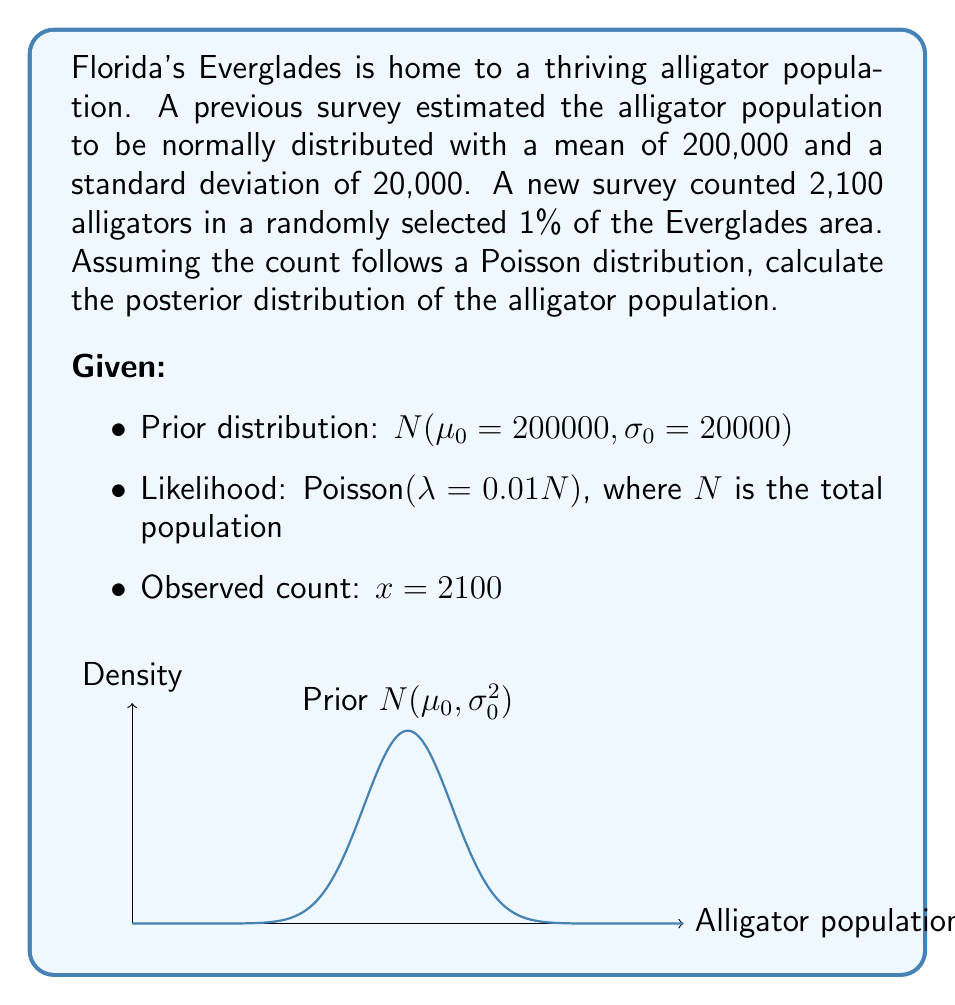Provide a solution to this math problem. Let's approach this step-by-step using Bayesian inference:

1) The prior distribution is Normal: $N(\mu_0 = 200000, \sigma_0 = 20000)$

2) The likelihood is Poisson: $P(x|\lambda) = \frac{e^{-\lambda}\lambda^x}{x!}$, where $\lambda = 0.01N$

3) For a Normal prior and Poisson likelihood, the posterior distribution is also Normal. We need to find its parameters.

4) The posterior mean $\mu_1$ and precision $\tau_1$ (inverse of variance) are given by:

   $$\tau_1 = \tau_0 + \frac{x}{\lambda^2}$$
   $$\mu_1 = \frac{\tau_0\mu_0 + x/\lambda}{\tau_1}$$

   where $\tau_0 = \frac{1}{\sigma_0^2}$

5) Calculate $\tau_0$:
   $$\tau_0 = \frac{1}{20000^2} = 2.5 \times 10^{-9}$$

6) Calculate $\tau_1$:
   $$\tau_1 = 2.5 \times 10^{-9} + \frac{2100}{(0.01N)^2} = 2.5 \times 10^{-9} + \frac{21000000}{N^2}$$

7) Calculate $\mu_1$:
   $$\mu_1 = \frac{2.5 \times 10^{-9} \times 200000 + 2100/(0.01)}{2.5 \times 10^{-9} + 21000000/N^2}$$

8) Simplify:
   $$\mu_1 = \frac{500 + 210000}{2.5 \times 10^{-9} + 21000000/N^2} = \frac{210500}{2.5 \times 10^{-9} + 21000000/N^2}$$

9) The posterior variance $\sigma_1^2$ is the inverse of $\tau_1$:
   $$\sigma_1^2 = \frac{1}{\tau_1} = \frac{1}{2.5 \times 10^{-9} + 21000000/N^2}$$

Therefore, the posterior distribution is Normal with mean $\mu_1$ and variance $\sigma_1^2$ as calculated above.
Answer: $N(\mu_1 = \frac{210500}{2.5 \times 10^{-9} + 21000000/N^2}, \sigma_1^2 = \frac{1}{2.5 \times 10^{-9} + 21000000/N^2})$ 